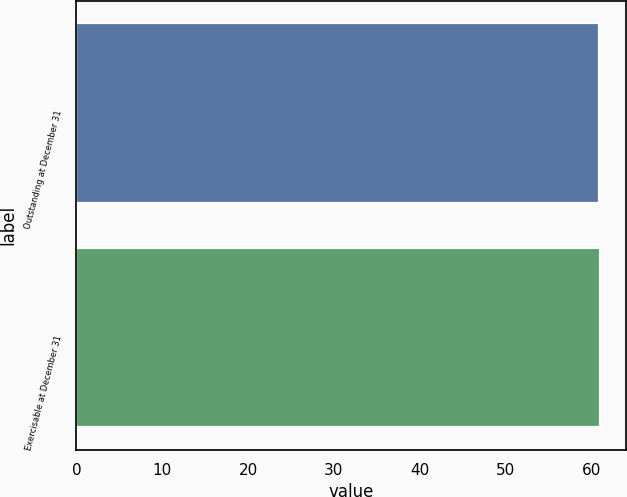Convert chart to OTSL. <chart><loc_0><loc_0><loc_500><loc_500><bar_chart><fcel>Outstanding at December 31<fcel>Exercisable at December 31<nl><fcel>60.93<fcel>61.03<nl></chart> 